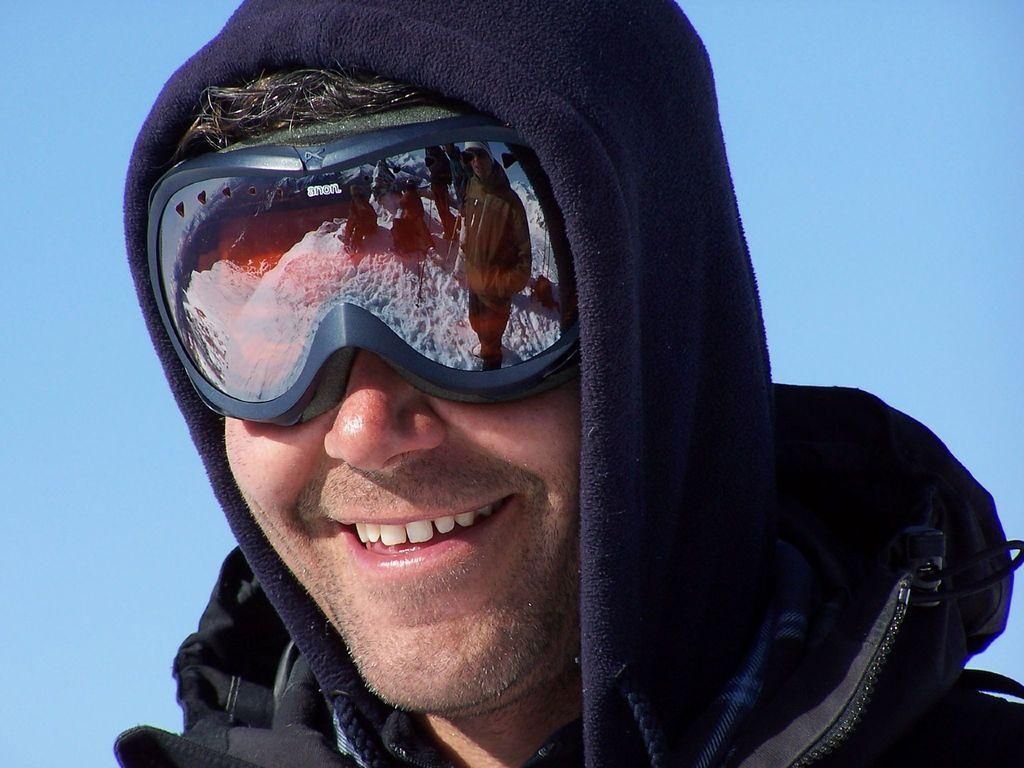What is the main subject of the image? There is a man in the image. What is the man doing in the image? The man is standing in the image. What is the man's facial expression in the image? The man is smiling in the image. What color is the man's dress in the image? The man is wearing a black dress in the image. What is the color of the sky in the image? The sky is blue in the image. How much dust can be seen on the man's dress in the image? There is no dust visible on the man's dress in the image. Is there a woman in the image? No, there is no woman present in the image; it features a man. 